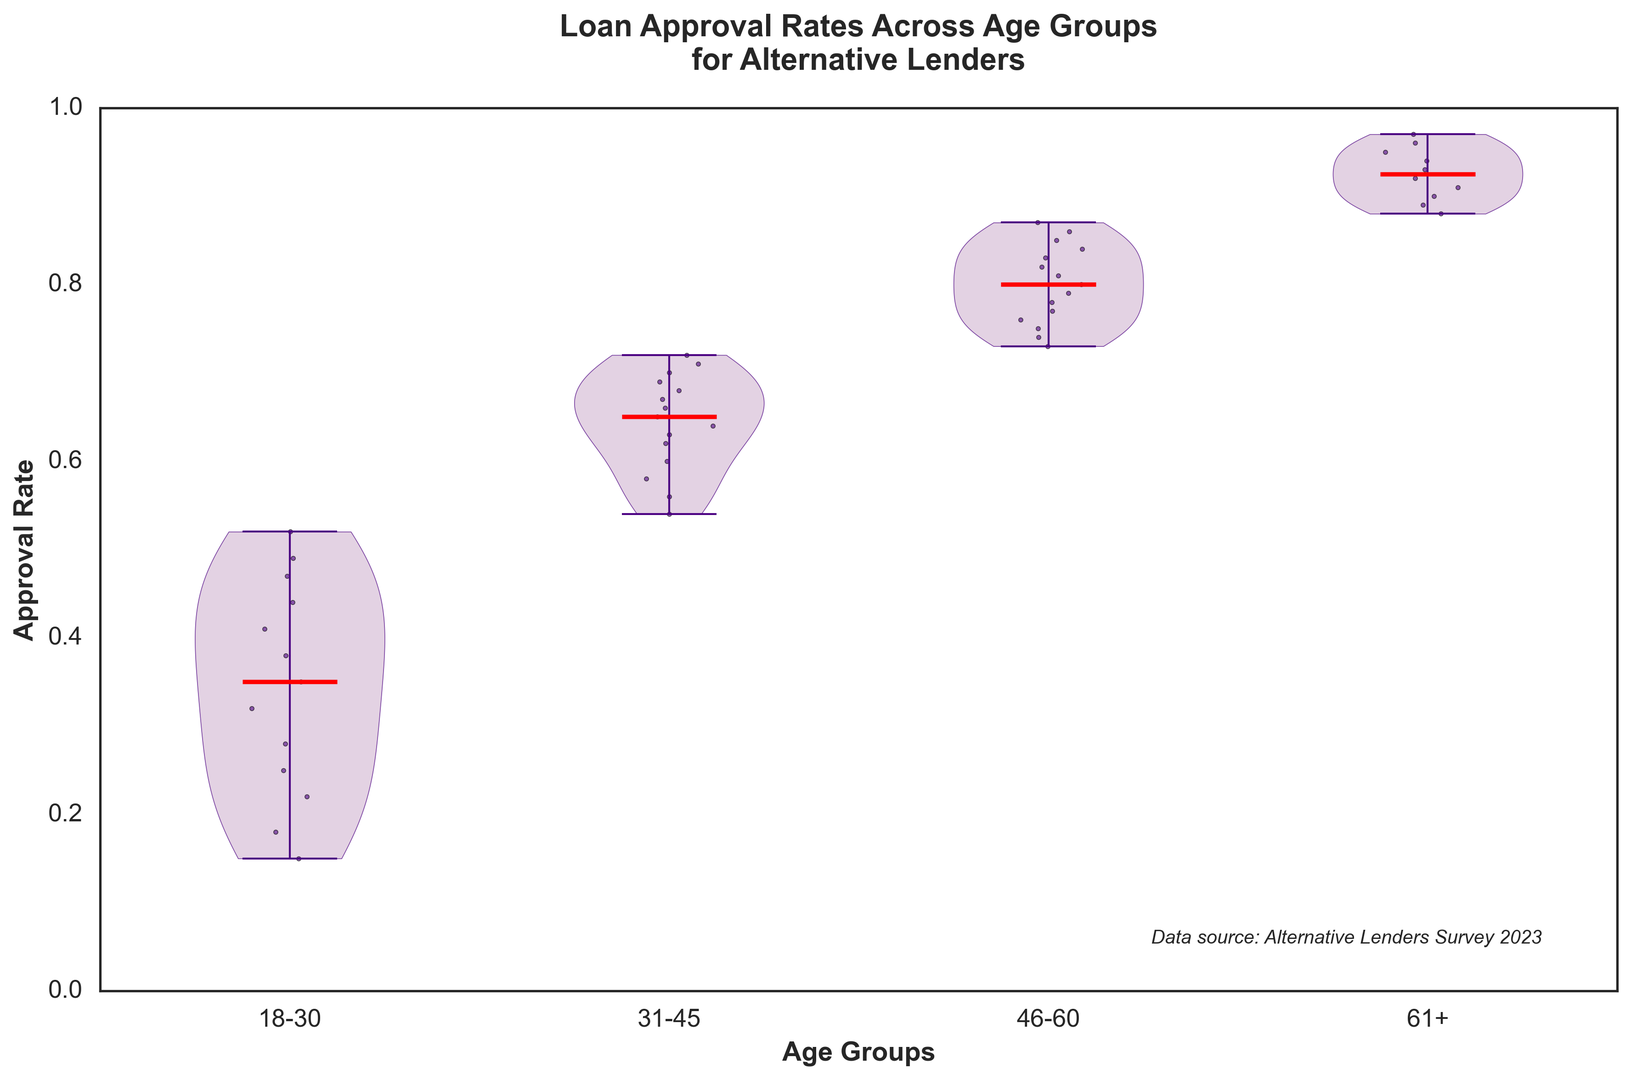Which age group has the highest median approval rate? To find the highest median approval rate, look at the violin plot's middle dot (which represents the median) for each age group. The age group with the highest median dot is '61+'
Answer: '61+' What is the range of approval rates for the age group '31-45'? The range is determined by the difference between the highest and lowest points of the violin plot for the age group '31-45'. The maximum approval rate is approximately 0.72, and the minimum is about 0.54, so the range is 0.72 - 0.54 = 0.18
Answer: 0.18 Which age group shows the most variability in approval rate? The variability in approval rates can be assessed by the width and spread of the violin plot. The '18-30' age group has the widest and most spread-out plot, indicating the highest variability
Answer: '18-30' How does the approval rate of the '46-60' age group compare to the '18-30' age group? Compare the height and distribution of the violins for '46-60' and '18-30'. The median and general distribution of '46-60' are higher than those of '18-30', indicating '46-60' has higher approval rates overall
Answer: '46-60' is higher What is the average approval rate for the '61+' age group? The average can be estimated by the center of the distribution. The '61+' age group has a median around 0.94, and all its values are closely packed around that, suggesting an average around 0.94
Answer: ~0.94 Between which neighboring age groups is there the steepest increase in median approval rate? Look at the median dots of each age group. From '31-45' to '46-60', there is a noticeable increase from about 0.66 to 0.80, which is the steepest increase
Answer: '31-45' to '46-60' Which age group has its approval rates closest to the median? This is determined by analyzing how closely packed the points are around the median. The '61+' age group has its points tightly clustered around the median, indicating the smallest spread
Answer: '61+' What visual attributes are used to represent the data points in the figure? The figure uses colors and scatter plots: the main violins are light purple with dark boundaries, and individual data points are represented as dark purple scatter dots
Answer: Colors and scatter points 